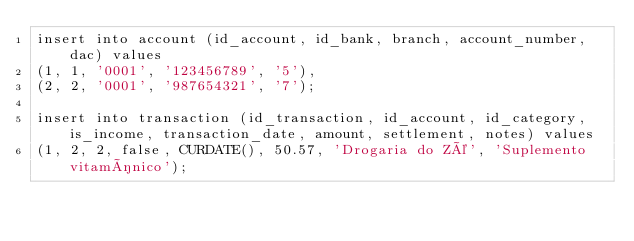<code> <loc_0><loc_0><loc_500><loc_500><_SQL_>insert into account (id_account, id_bank, branch, account_number, dac) values
(1, 1, '0001', '123456789', '5'),
(2, 2, '0001', '987654321', '7');

insert into transaction (id_transaction, id_account, id_category, is_income, transaction_date, amount, settlement, notes) values
(1, 2, 2, false, CURDATE(), 50.57, 'Drogaria do Zé', 'Suplemento vitamínico');</code> 